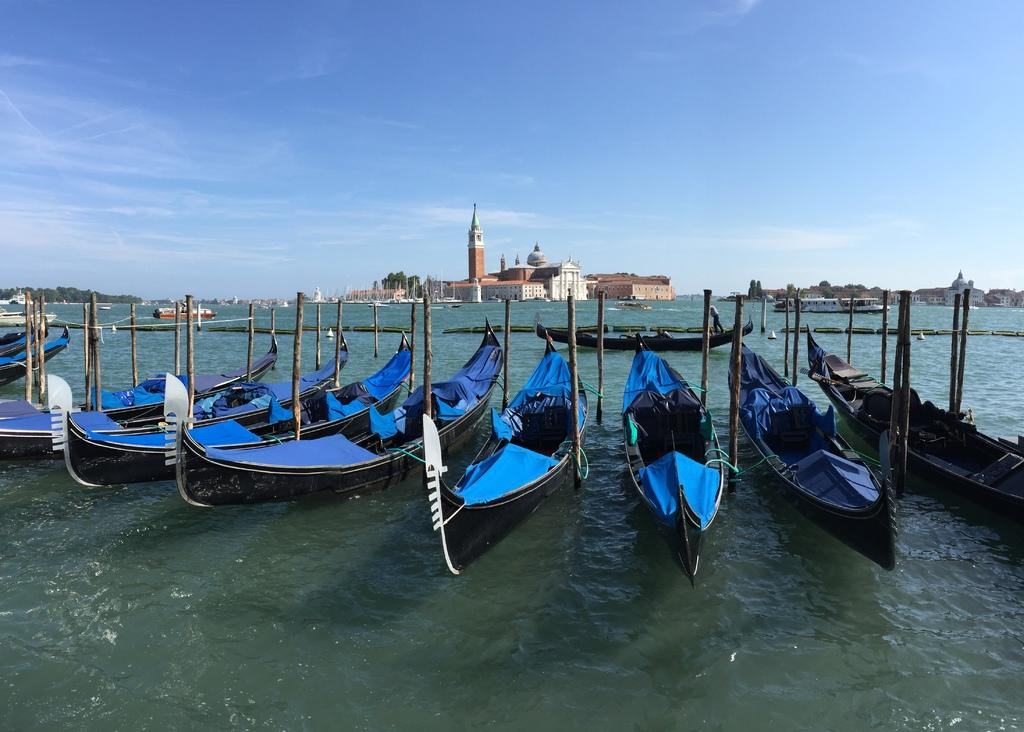What is floating on the water surface in the image? There are boats on the water surface in the image. What type of structures can be seen in the image? There are wooden poles in the image. What can be seen in the distance in the image? There are buildings and trees in the background of the image. What is visible above the buildings and trees in the image? The sky is visible in the background of the image. Are there any ghosts visible in the image? There are no ghosts present in the image; it features boats on the water surface, wooden poles, buildings, trees, and the sky. What nation is represented by the boats in the image? The image does not provide information about the nationality of the boats or the people in the image, so it cannot be determined from the image. 